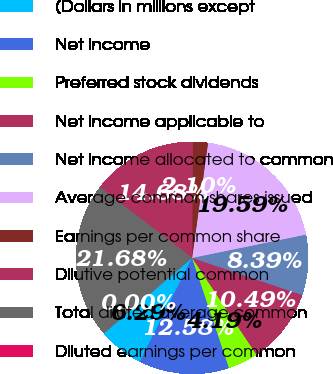<chart> <loc_0><loc_0><loc_500><loc_500><pie_chart><fcel>(Dollars in millions except<fcel>Net income<fcel>Preferred stock dividends<fcel>Net income applicable to<fcel>Net income allocated to common<fcel>Average common shares issued<fcel>Earnings per common share<fcel>Dilutive potential common<fcel>Total diluted average common<fcel>Diluted earnings per common<nl><fcel>6.29%<fcel>12.58%<fcel>4.19%<fcel>10.49%<fcel>8.39%<fcel>19.59%<fcel>2.1%<fcel>14.68%<fcel>21.68%<fcel>0.0%<nl></chart> 